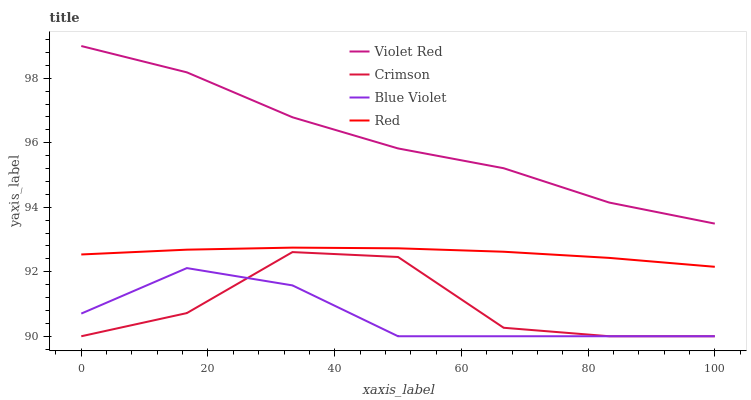Does Red have the minimum area under the curve?
Answer yes or no. No. Does Red have the maximum area under the curve?
Answer yes or no. No. Is Violet Red the smoothest?
Answer yes or no. No. Is Violet Red the roughest?
Answer yes or no. No. Does Red have the lowest value?
Answer yes or no. No. Does Red have the highest value?
Answer yes or no. No. Is Crimson less than Red?
Answer yes or no. Yes. Is Red greater than Crimson?
Answer yes or no. Yes. Does Crimson intersect Red?
Answer yes or no. No. 